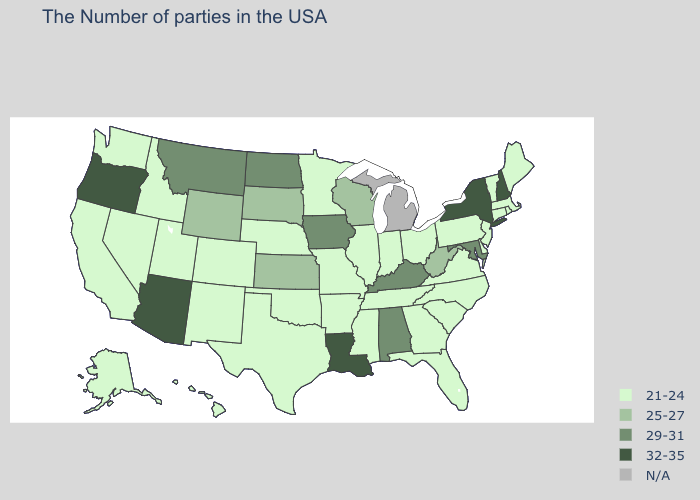What is the value of Arkansas?
Quick response, please. 21-24. What is the lowest value in the West?
Short answer required. 21-24. Name the states that have a value in the range 21-24?
Be succinct. Maine, Massachusetts, Rhode Island, Vermont, Connecticut, New Jersey, Delaware, Pennsylvania, Virginia, North Carolina, South Carolina, Ohio, Florida, Georgia, Indiana, Tennessee, Illinois, Mississippi, Missouri, Arkansas, Minnesota, Nebraska, Oklahoma, Texas, Colorado, New Mexico, Utah, Idaho, Nevada, California, Washington, Alaska, Hawaii. What is the highest value in the MidWest ?
Keep it brief. 29-31. Name the states that have a value in the range 29-31?
Give a very brief answer. Maryland, Kentucky, Alabama, Iowa, North Dakota, Montana. What is the value of Missouri?
Keep it brief. 21-24. Name the states that have a value in the range 21-24?
Answer briefly. Maine, Massachusetts, Rhode Island, Vermont, Connecticut, New Jersey, Delaware, Pennsylvania, Virginia, North Carolina, South Carolina, Ohio, Florida, Georgia, Indiana, Tennessee, Illinois, Mississippi, Missouri, Arkansas, Minnesota, Nebraska, Oklahoma, Texas, Colorado, New Mexico, Utah, Idaho, Nevada, California, Washington, Alaska, Hawaii. Which states have the highest value in the USA?
Answer briefly. New Hampshire, New York, Louisiana, Arizona, Oregon. Which states have the lowest value in the South?
Concise answer only. Delaware, Virginia, North Carolina, South Carolina, Florida, Georgia, Tennessee, Mississippi, Arkansas, Oklahoma, Texas. What is the value of New Jersey?
Answer briefly. 21-24. Does the first symbol in the legend represent the smallest category?
Write a very short answer. Yes. Name the states that have a value in the range 29-31?
Write a very short answer. Maryland, Kentucky, Alabama, Iowa, North Dakota, Montana. Among the states that border California , which have the lowest value?
Write a very short answer. Nevada. What is the highest value in the USA?
Write a very short answer. 32-35. What is the lowest value in the South?
Give a very brief answer. 21-24. 